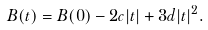<formula> <loc_0><loc_0><loc_500><loc_500>B ( t ) = B ( 0 ) - 2 c | t | + 3 d | t | ^ { 2 } .</formula> 